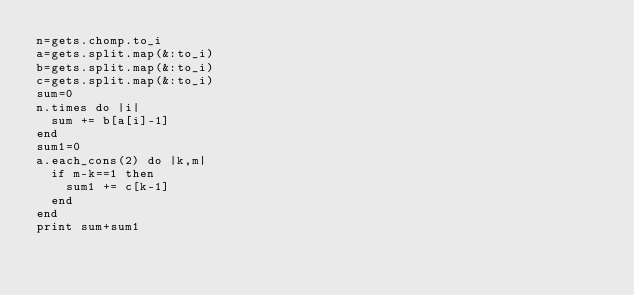<code> <loc_0><loc_0><loc_500><loc_500><_Ruby_>n=gets.chomp.to_i
a=gets.split.map(&:to_i)
b=gets.split.map(&:to_i)
c=gets.split.map(&:to_i)
sum=0
n.times do |i|
  sum += b[a[i]-1]
end
sum1=0
a.each_cons(2) do |k,m|
  if m-k==1 then
    sum1 += c[k-1]
  end
end
print sum+sum1
</code> 